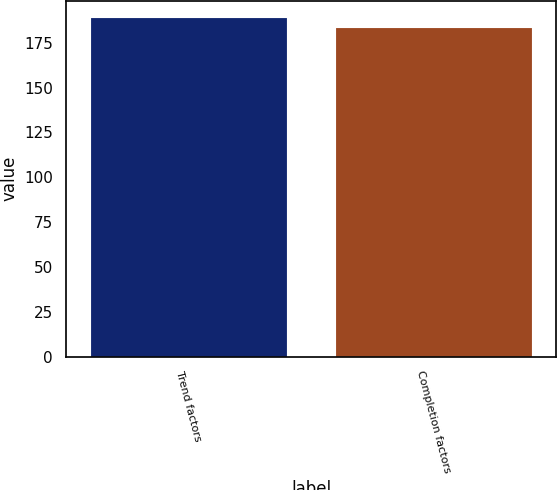Convert chart to OTSL. <chart><loc_0><loc_0><loc_500><loc_500><bar_chart><fcel>Trend factors<fcel>Completion factors<nl><fcel>189<fcel>183<nl></chart> 